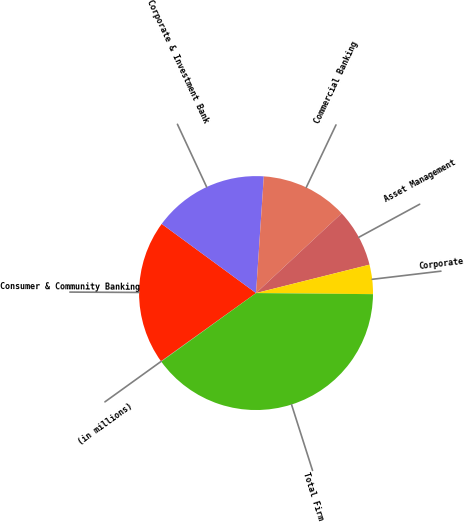<chart> <loc_0><loc_0><loc_500><loc_500><pie_chart><fcel>(in millions)<fcel>Consumer & Community Banking<fcel>Corporate & Investment Bank<fcel>Commercial Banking<fcel>Asset Management<fcel>Corporate<fcel>Total Firm<nl><fcel>0.06%<fcel>19.97%<fcel>15.99%<fcel>12.01%<fcel>8.03%<fcel>4.05%<fcel>39.89%<nl></chart> 